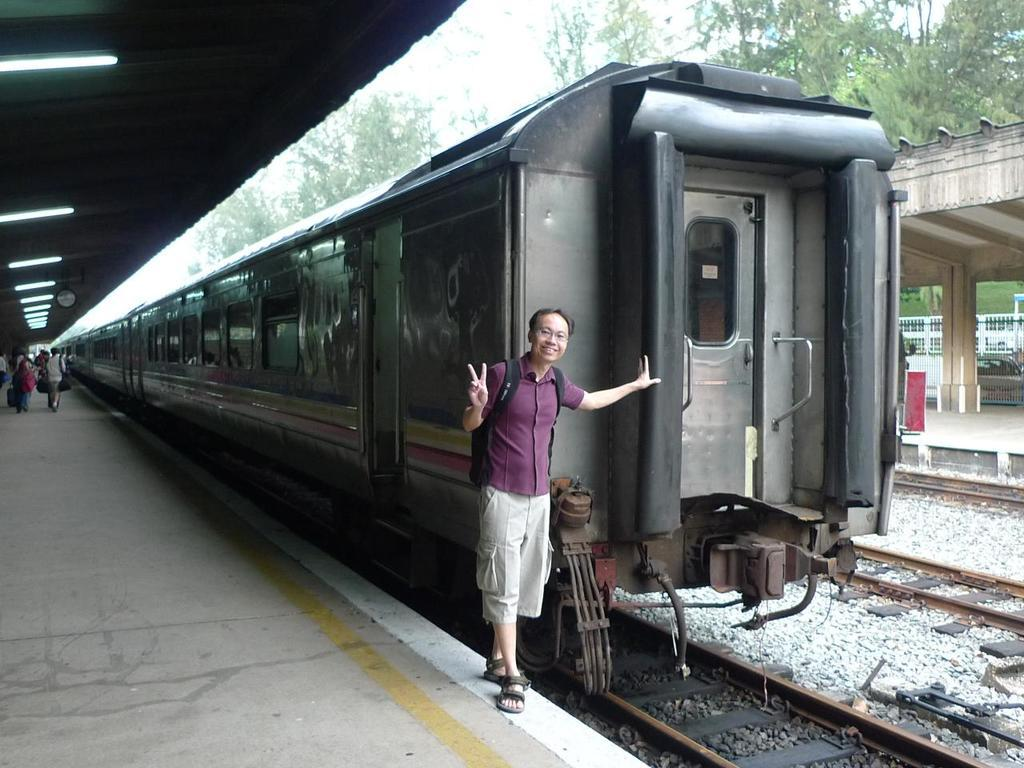What is the main subject of the image? There is a person standing beside a train in the image. What is the person doing? The person is taking pictures. Are there any other people in the image? Yes, there are people walking on the platform in the image. Can you see a pan being used by the person taking pictures in the image? There is no pan visible in the image; the person is taking pictures with a camera or a phone. Is there a dog present in the image? No, there is no dog present in the image. 